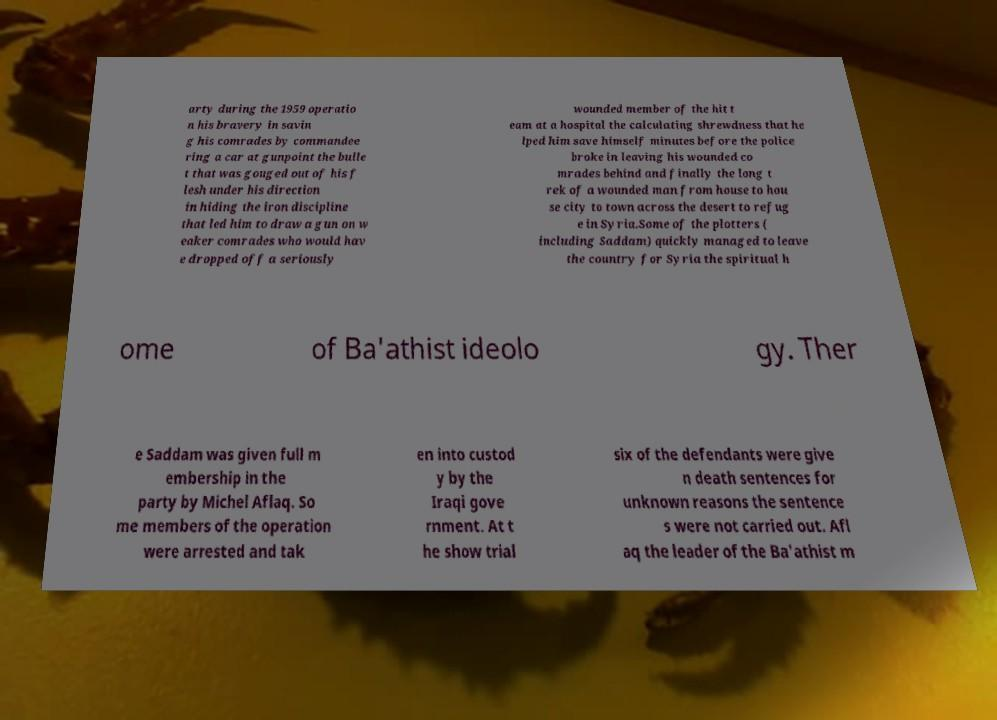I need the written content from this picture converted into text. Can you do that? arty during the 1959 operatio n his bravery in savin g his comrades by commandee ring a car at gunpoint the bulle t that was gouged out of his f lesh under his direction in hiding the iron discipline that led him to draw a gun on w eaker comrades who would hav e dropped off a seriously wounded member of the hit t eam at a hospital the calculating shrewdness that he lped him save himself minutes before the police broke in leaving his wounded co mrades behind and finally the long t rek of a wounded man from house to hou se city to town across the desert to refug e in Syria.Some of the plotters ( including Saddam) quickly managed to leave the country for Syria the spiritual h ome of Ba'athist ideolo gy. Ther e Saddam was given full m embership in the party by Michel Aflaq. So me members of the operation were arrested and tak en into custod y by the Iraqi gove rnment. At t he show trial six of the defendants were give n death sentences for unknown reasons the sentence s were not carried out. Afl aq the leader of the Ba'athist m 